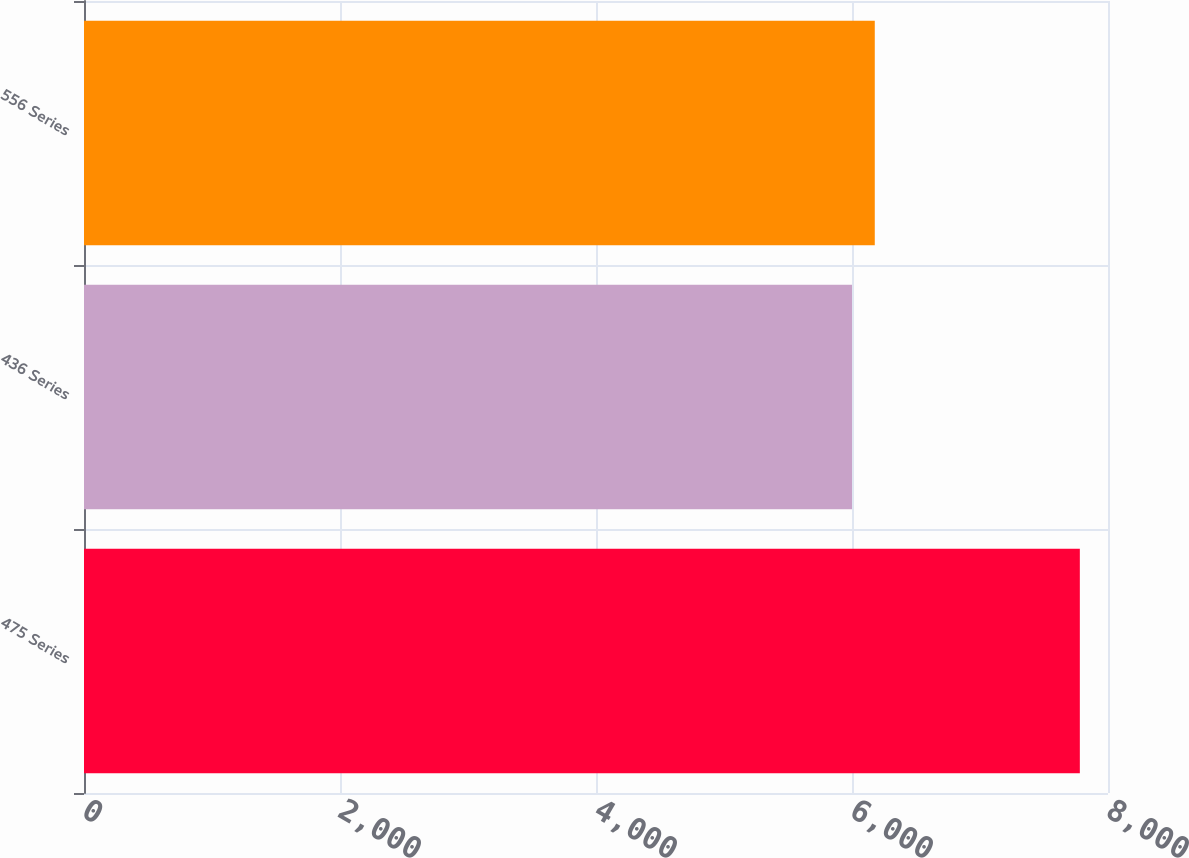Convert chart to OTSL. <chart><loc_0><loc_0><loc_500><loc_500><bar_chart><fcel>475 Series<fcel>436 Series<fcel>556 Series<nl><fcel>7780<fcel>6000<fcel>6178<nl></chart> 